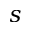<formula> <loc_0><loc_0><loc_500><loc_500>s</formula> 